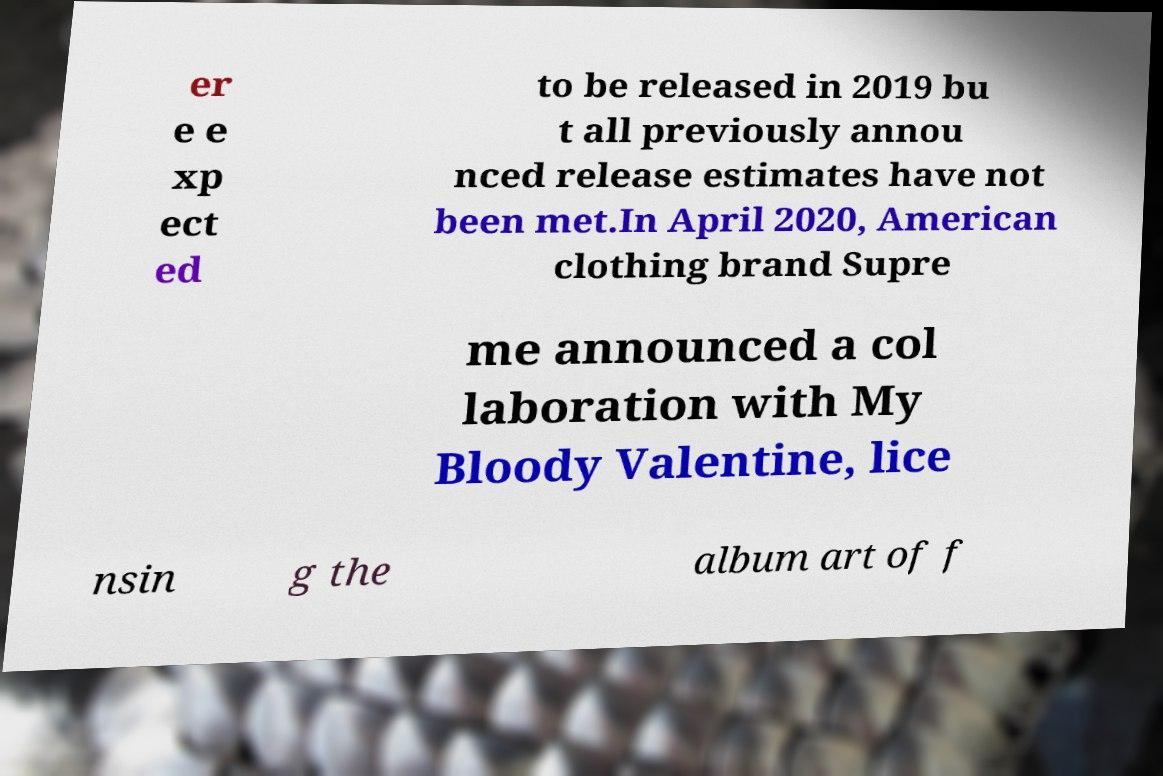Please read and relay the text visible in this image. What does it say? er e e xp ect ed to be released in 2019 bu t all previously annou nced release estimates have not been met.In April 2020, American clothing brand Supre me announced a col laboration with My Bloody Valentine, lice nsin g the album art of f 